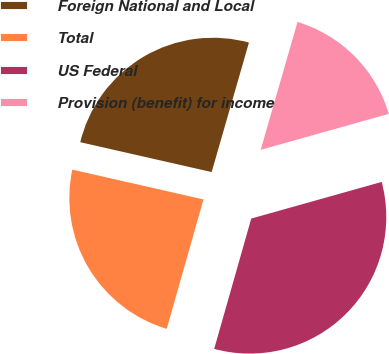<chart> <loc_0><loc_0><loc_500><loc_500><pie_chart><fcel>Foreign National and Local<fcel>Total<fcel>US Federal<fcel>Provision (benefit) for income<nl><fcel>25.91%<fcel>24.15%<fcel>33.77%<fcel>16.18%<nl></chart> 